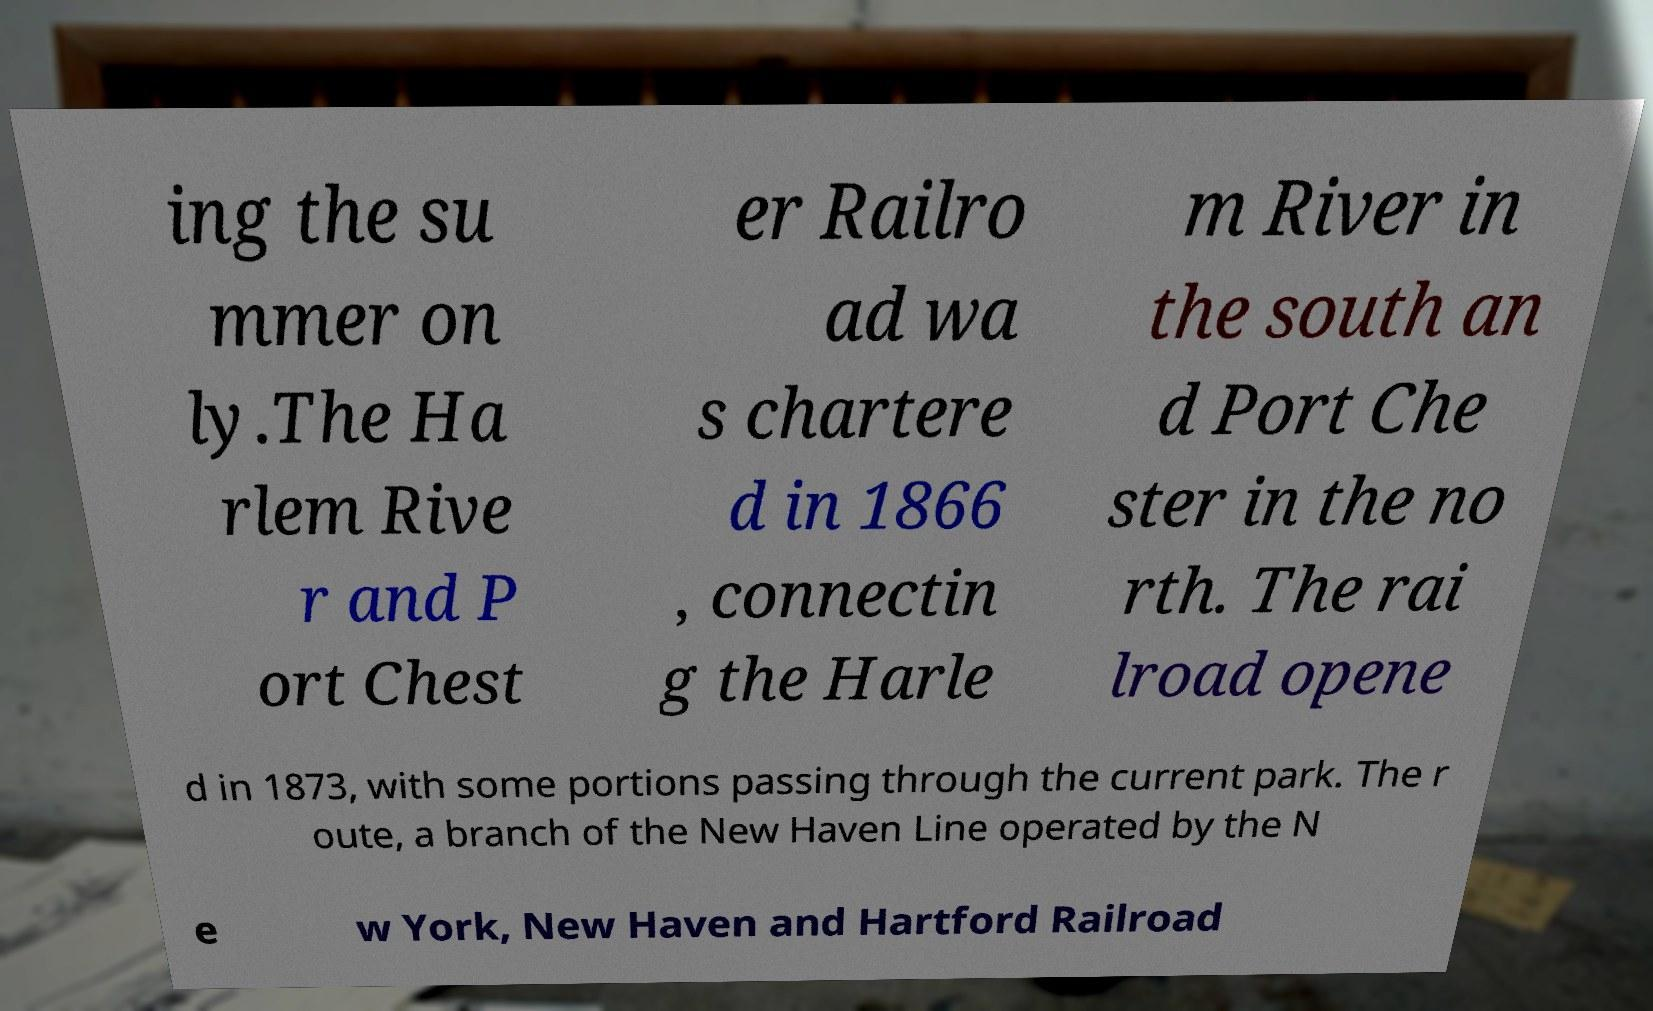There's text embedded in this image that I need extracted. Can you transcribe it verbatim? ing the su mmer on ly.The Ha rlem Rive r and P ort Chest er Railro ad wa s chartere d in 1866 , connectin g the Harle m River in the south an d Port Che ster in the no rth. The rai lroad opene d in 1873, with some portions passing through the current park. The r oute, a branch of the New Haven Line operated by the N e w York, New Haven and Hartford Railroad 